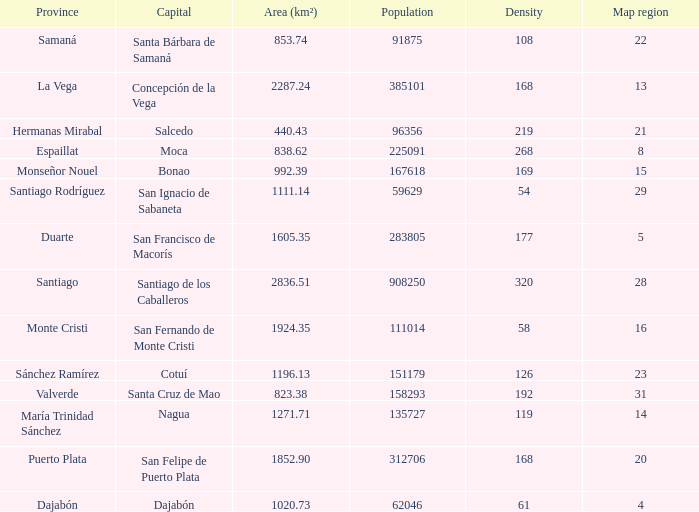When province is monseñor nouel, what is the area (km²)? 992.39. 